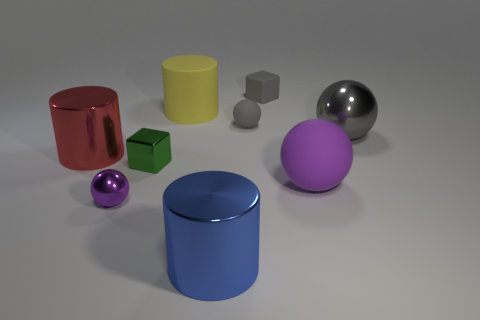Can you describe the lighting direction in the scene? The lighting appears to be coming from the upper left, as indicated by the shadows cast to the right of the objects and the highlights on the left sides of the objects. 